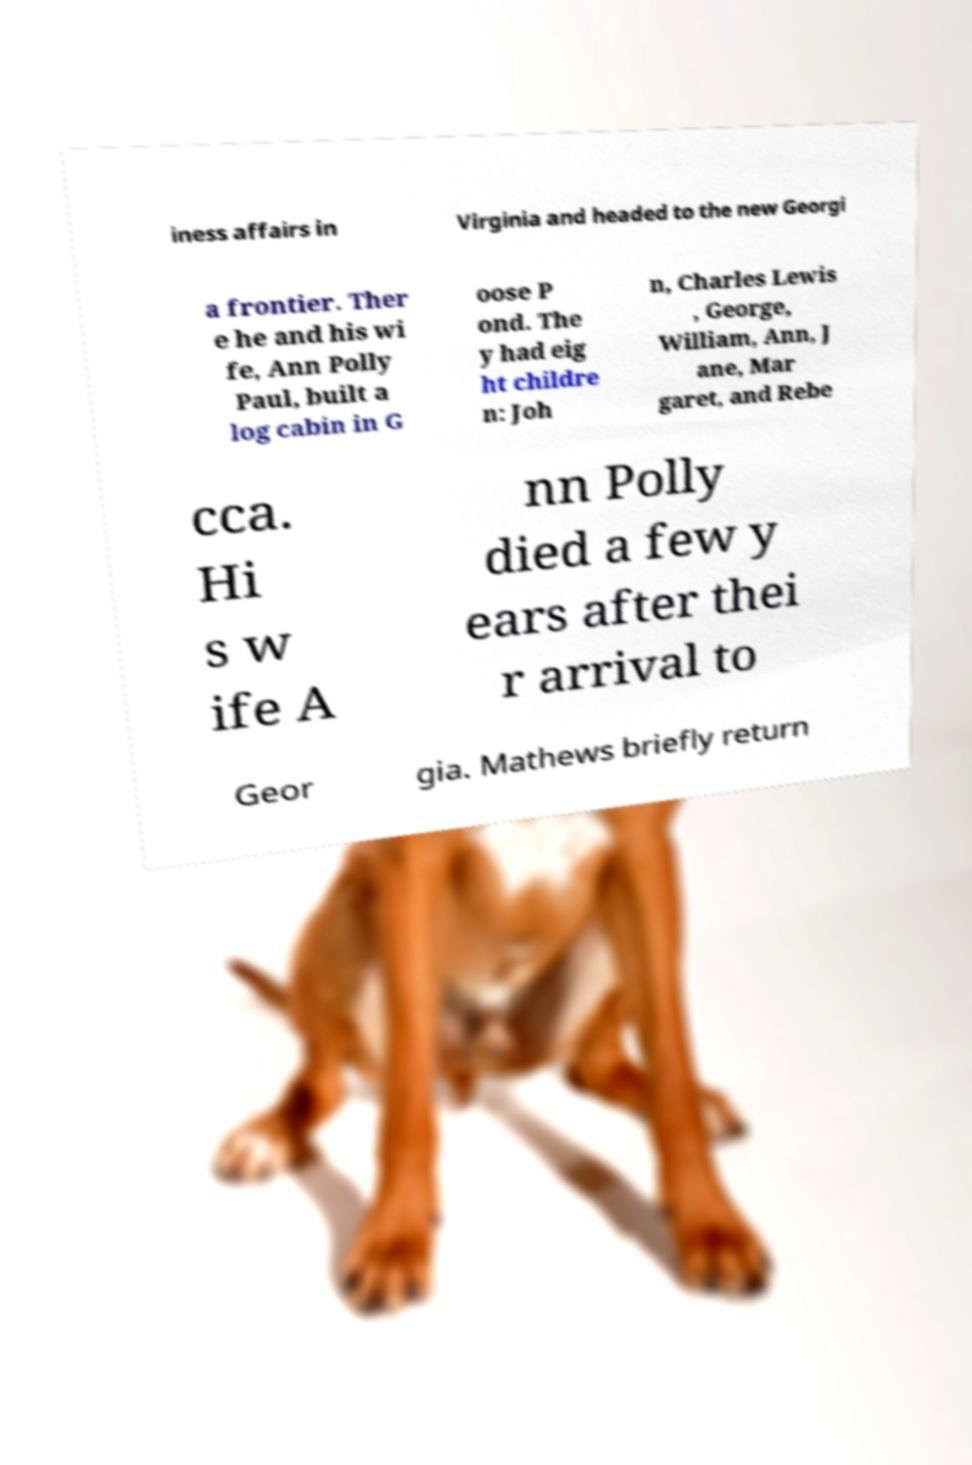Please read and relay the text visible in this image. What does it say? iness affairs in Virginia and headed to the new Georgi a frontier. Ther e he and his wi fe, Ann Polly Paul, built a log cabin in G oose P ond. The y had eig ht childre n: Joh n, Charles Lewis , George, William, Ann, J ane, Mar garet, and Rebe cca. Hi s w ife A nn Polly died a few y ears after thei r arrival to Geor gia. Mathews briefly return 